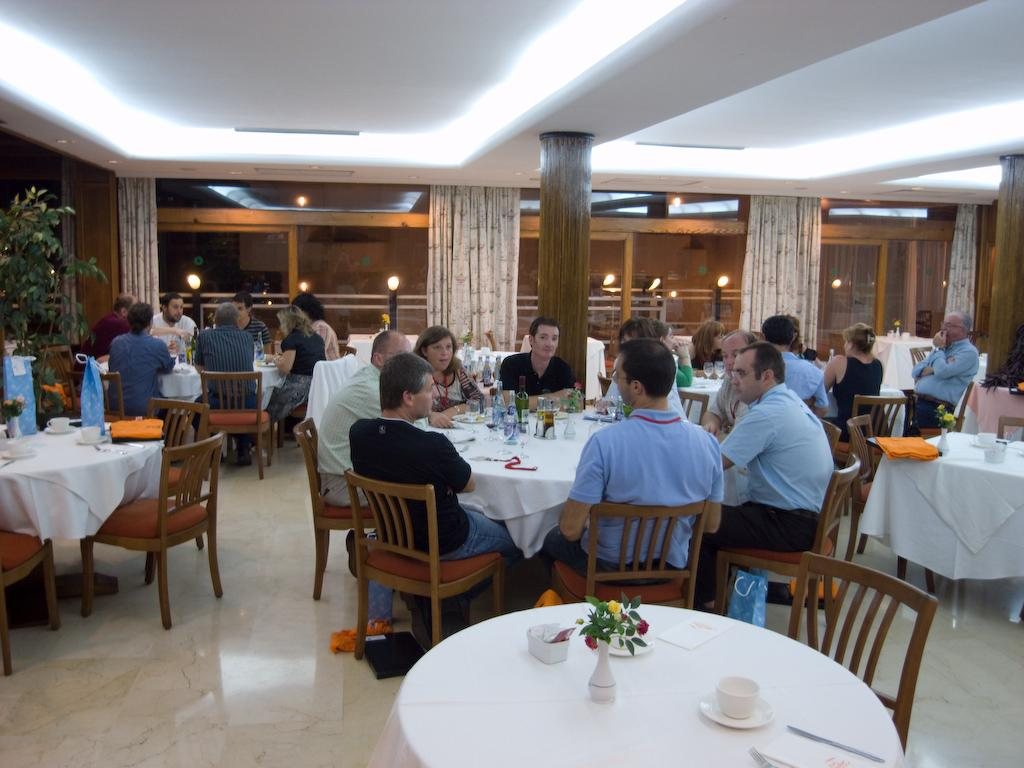What is happening in the image involving a group of people? There is a group of people in the image, and they are seated on chairs. What can be found on the table in the image? There are bottles and cups on the table in the image. What type of window treatment is present in the image? There are curtains hanging near the windows in the image. What type of vegetation is present in the image? There is a plant in the image. What type of produce is being harvested in the image? There is no produce being harvested in the image; it features a group of people seated on chairs with bottles, cups, curtains, and a plant. 